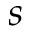<formula> <loc_0><loc_0><loc_500><loc_500>s</formula> 